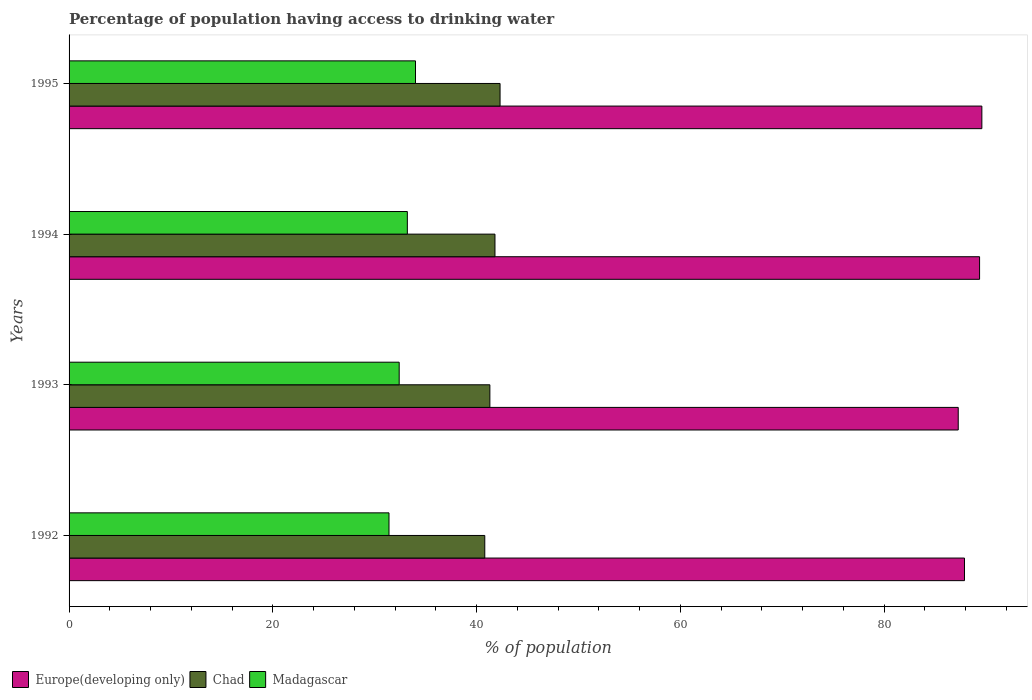What is the percentage of population having access to drinking water in Chad in 1992?
Offer a very short reply. 40.8. Across all years, what is the maximum percentage of population having access to drinking water in Chad?
Your answer should be compact. 42.3. Across all years, what is the minimum percentage of population having access to drinking water in Madagascar?
Ensure brevity in your answer.  31.4. In which year was the percentage of population having access to drinking water in Madagascar minimum?
Provide a succinct answer. 1992. What is the total percentage of population having access to drinking water in Europe(developing only) in the graph?
Give a very brief answer. 354.09. What is the difference between the percentage of population having access to drinking water in Madagascar in 1993 and the percentage of population having access to drinking water in Europe(developing only) in 1992?
Your response must be concise. -55.48. What is the average percentage of population having access to drinking water in Madagascar per year?
Your response must be concise. 32.75. In the year 1992, what is the difference between the percentage of population having access to drinking water in Madagascar and percentage of population having access to drinking water in Europe(developing only)?
Ensure brevity in your answer.  -56.48. What is the ratio of the percentage of population having access to drinking water in Chad in 1993 to that in 1995?
Keep it short and to the point. 0.98. Is the percentage of population having access to drinking water in Chad in 1992 less than that in 1994?
Your answer should be very brief. Yes. Is the difference between the percentage of population having access to drinking water in Madagascar in 1993 and 1995 greater than the difference between the percentage of population having access to drinking water in Europe(developing only) in 1993 and 1995?
Your response must be concise. Yes. What is the difference between the highest and the second highest percentage of population having access to drinking water in Europe(developing only)?
Provide a short and direct response. 0.22. In how many years, is the percentage of population having access to drinking water in Madagascar greater than the average percentage of population having access to drinking water in Madagascar taken over all years?
Give a very brief answer. 2. What does the 2nd bar from the top in 1995 represents?
Ensure brevity in your answer.  Chad. What does the 2nd bar from the bottom in 1993 represents?
Make the answer very short. Chad. How many bars are there?
Make the answer very short. 12. Are all the bars in the graph horizontal?
Offer a very short reply. Yes. What is the difference between two consecutive major ticks on the X-axis?
Keep it short and to the point. 20. Are the values on the major ticks of X-axis written in scientific E-notation?
Your answer should be compact. No. Does the graph contain any zero values?
Offer a very short reply. No. Does the graph contain grids?
Give a very brief answer. No. Where does the legend appear in the graph?
Offer a very short reply. Bottom left. What is the title of the graph?
Offer a terse response. Percentage of population having access to drinking water. What is the label or title of the X-axis?
Ensure brevity in your answer.  % of population. What is the % of population of Europe(developing only) in 1992?
Your answer should be compact. 87.88. What is the % of population of Chad in 1992?
Your response must be concise. 40.8. What is the % of population in Madagascar in 1992?
Offer a terse response. 31.4. What is the % of population in Europe(developing only) in 1993?
Offer a very short reply. 87.27. What is the % of population of Chad in 1993?
Your answer should be very brief. 41.3. What is the % of population in Madagascar in 1993?
Your answer should be compact. 32.4. What is the % of population of Europe(developing only) in 1994?
Your response must be concise. 89.36. What is the % of population of Chad in 1994?
Your response must be concise. 41.8. What is the % of population of Madagascar in 1994?
Provide a short and direct response. 33.2. What is the % of population of Europe(developing only) in 1995?
Offer a very short reply. 89.59. What is the % of population of Chad in 1995?
Provide a succinct answer. 42.3. Across all years, what is the maximum % of population in Europe(developing only)?
Provide a succinct answer. 89.59. Across all years, what is the maximum % of population in Chad?
Give a very brief answer. 42.3. Across all years, what is the minimum % of population of Europe(developing only)?
Your response must be concise. 87.27. Across all years, what is the minimum % of population in Chad?
Provide a succinct answer. 40.8. Across all years, what is the minimum % of population in Madagascar?
Give a very brief answer. 31.4. What is the total % of population in Europe(developing only) in the graph?
Provide a succinct answer. 354.09. What is the total % of population in Chad in the graph?
Your response must be concise. 166.2. What is the total % of population in Madagascar in the graph?
Give a very brief answer. 131. What is the difference between the % of population of Europe(developing only) in 1992 and that in 1993?
Ensure brevity in your answer.  0.61. What is the difference between the % of population in Madagascar in 1992 and that in 1993?
Provide a short and direct response. -1. What is the difference between the % of population of Europe(developing only) in 1992 and that in 1994?
Offer a very short reply. -1.48. What is the difference between the % of population in Europe(developing only) in 1992 and that in 1995?
Keep it short and to the point. -1.71. What is the difference between the % of population of Chad in 1992 and that in 1995?
Make the answer very short. -1.5. What is the difference between the % of population in Madagascar in 1992 and that in 1995?
Your answer should be very brief. -2.6. What is the difference between the % of population in Europe(developing only) in 1993 and that in 1994?
Your answer should be very brief. -2.09. What is the difference between the % of population of Europe(developing only) in 1993 and that in 1995?
Give a very brief answer. -2.32. What is the difference between the % of population of Madagascar in 1993 and that in 1995?
Give a very brief answer. -1.6. What is the difference between the % of population of Europe(developing only) in 1994 and that in 1995?
Your response must be concise. -0.22. What is the difference between the % of population in Chad in 1994 and that in 1995?
Your answer should be very brief. -0.5. What is the difference between the % of population in Madagascar in 1994 and that in 1995?
Your response must be concise. -0.8. What is the difference between the % of population of Europe(developing only) in 1992 and the % of population of Chad in 1993?
Give a very brief answer. 46.58. What is the difference between the % of population in Europe(developing only) in 1992 and the % of population in Madagascar in 1993?
Your answer should be compact. 55.48. What is the difference between the % of population of Europe(developing only) in 1992 and the % of population of Chad in 1994?
Keep it short and to the point. 46.08. What is the difference between the % of population of Europe(developing only) in 1992 and the % of population of Madagascar in 1994?
Your response must be concise. 54.68. What is the difference between the % of population of Europe(developing only) in 1992 and the % of population of Chad in 1995?
Your answer should be compact. 45.58. What is the difference between the % of population in Europe(developing only) in 1992 and the % of population in Madagascar in 1995?
Keep it short and to the point. 53.88. What is the difference between the % of population in Europe(developing only) in 1993 and the % of population in Chad in 1994?
Ensure brevity in your answer.  45.47. What is the difference between the % of population of Europe(developing only) in 1993 and the % of population of Madagascar in 1994?
Your response must be concise. 54.07. What is the difference between the % of population in Chad in 1993 and the % of population in Madagascar in 1994?
Offer a very short reply. 8.1. What is the difference between the % of population in Europe(developing only) in 1993 and the % of population in Chad in 1995?
Make the answer very short. 44.97. What is the difference between the % of population in Europe(developing only) in 1993 and the % of population in Madagascar in 1995?
Offer a terse response. 53.27. What is the difference between the % of population of Chad in 1993 and the % of population of Madagascar in 1995?
Your response must be concise. 7.3. What is the difference between the % of population in Europe(developing only) in 1994 and the % of population in Chad in 1995?
Offer a terse response. 47.06. What is the difference between the % of population in Europe(developing only) in 1994 and the % of population in Madagascar in 1995?
Your answer should be very brief. 55.36. What is the difference between the % of population of Chad in 1994 and the % of population of Madagascar in 1995?
Your response must be concise. 7.8. What is the average % of population of Europe(developing only) per year?
Your answer should be compact. 88.52. What is the average % of population of Chad per year?
Offer a terse response. 41.55. What is the average % of population in Madagascar per year?
Give a very brief answer. 32.75. In the year 1992, what is the difference between the % of population in Europe(developing only) and % of population in Chad?
Offer a terse response. 47.08. In the year 1992, what is the difference between the % of population in Europe(developing only) and % of population in Madagascar?
Provide a succinct answer. 56.48. In the year 1993, what is the difference between the % of population in Europe(developing only) and % of population in Chad?
Your answer should be very brief. 45.97. In the year 1993, what is the difference between the % of population in Europe(developing only) and % of population in Madagascar?
Provide a succinct answer. 54.87. In the year 1994, what is the difference between the % of population of Europe(developing only) and % of population of Chad?
Your answer should be compact. 47.56. In the year 1994, what is the difference between the % of population in Europe(developing only) and % of population in Madagascar?
Offer a very short reply. 56.16. In the year 1995, what is the difference between the % of population in Europe(developing only) and % of population in Chad?
Make the answer very short. 47.29. In the year 1995, what is the difference between the % of population in Europe(developing only) and % of population in Madagascar?
Give a very brief answer. 55.59. What is the ratio of the % of population of Europe(developing only) in 1992 to that in 1993?
Your response must be concise. 1.01. What is the ratio of the % of population in Chad in 1992 to that in 1993?
Provide a short and direct response. 0.99. What is the ratio of the % of population in Madagascar in 1992 to that in 1993?
Provide a short and direct response. 0.97. What is the ratio of the % of population in Europe(developing only) in 1992 to that in 1994?
Offer a terse response. 0.98. What is the ratio of the % of population in Chad in 1992 to that in 1994?
Your answer should be very brief. 0.98. What is the ratio of the % of population in Madagascar in 1992 to that in 1994?
Your response must be concise. 0.95. What is the ratio of the % of population of Europe(developing only) in 1992 to that in 1995?
Your response must be concise. 0.98. What is the ratio of the % of population of Chad in 1992 to that in 1995?
Ensure brevity in your answer.  0.96. What is the ratio of the % of population of Madagascar in 1992 to that in 1995?
Make the answer very short. 0.92. What is the ratio of the % of population in Europe(developing only) in 1993 to that in 1994?
Offer a terse response. 0.98. What is the ratio of the % of population in Chad in 1993 to that in 1994?
Provide a succinct answer. 0.99. What is the ratio of the % of population of Madagascar in 1993 to that in 1994?
Give a very brief answer. 0.98. What is the ratio of the % of population of Europe(developing only) in 1993 to that in 1995?
Provide a short and direct response. 0.97. What is the ratio of the % of population of Chad in 1993 to that in 1995?
Your answer should be very brief. 0.98. What is the ratio of the % of population of Madagascar in 1993 to that in 1995?
Provide a short and direct response. 0.95. What is the ratio of the % of population in Europe(developing only) in 1994 to that in 1995?
Your answer should be compact. 1. What is the ratio of the % of population in Madagascar in 1994 to that in 1995?
Provide a short and direct response. 0.98. What is the difference between the highest and the second highest % of population of Europe(developing only)?
Your answer should be compact. 0.22. What is the difference between the highest and the second highest % of population of Chad?
Your response must be concise. 0.5. What is the difference between the highest and the second highest % of population of Madagascar?
Make the answer very short. 0.8. What is the difference between the highest and the lowest % of population in Europe(developing only)?
Offer a very short reply. 2.32. What is the difference between the highest and the lowest % of population of Chad?
Provide a short and direct response. 1.5. 